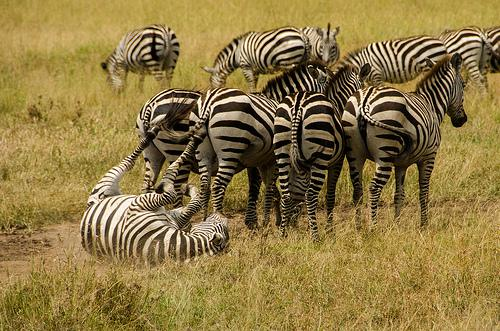Question: how many zebras are pictured?
Choices:
A. 11.
B. 6.
C. 5.
D. 8.
Answer with the letter. Answer: A Question: who is in the picture?
Choices:
A. Giraffes.
B. Lions.
C. Zebras.
D. Bears.
Answer with the letter. Answer: C Question: when was the picture taken?
Choices:
A. Morning.
B. Night.
C. Sunset.
D. Daytime.
Answer with the letter. Answer: D Question: what are the zebras eating?
Choices:
A. Leaves.
B. Bugs.
C. Bamboo.
D. Grass.
Answer with the letter. Answer: D Question: where are the zebras?
Choices:
A. In a jungle.
B. In a zoo.
C. In a field.
D. In a park.
Answer with the letter. Answer: C Question: what are the zebras in back doing?
Choices:
A. Hunting.
B. Sleeping.
C. Mating.
D. Grazing.
Answer with the letter. Answer: D Question: why is the zebra on the ground?
Choices:
A. Scratching its back.
B. Sleeping.
C. Hunting.
D. Eating.
Answer with the letter. Answer: A 